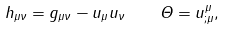Convert formula to latex. <formula><loc_0><loc_0><loc_500><loc_500>h _ { \mu \nu } = g _ { \mu \nu } - u { _ { \mu } } u _ { \nu } \, \quad \, \Theta = u ^ { \mu } _ { ; \mu } ,</formula> 